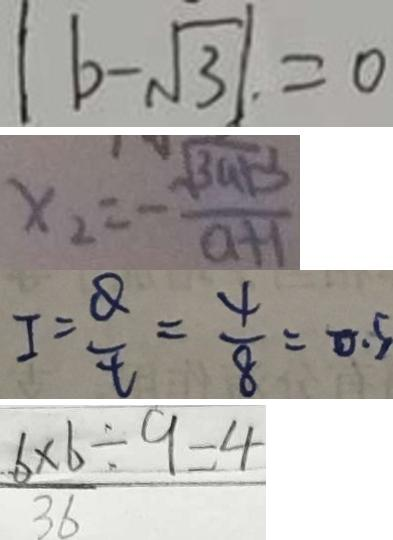Convert formula to latex. <formula><loc_0><loc_0><loc_500><loc_500>\vert b - \sqrt { 3 } \vert . = 0 
 x _ { 2 } = - \frac { \sqrt { 3 a + 3 } } { a + 1 } 
 I = \frac { Q } { t } = \frac { 4 } { 8 } = 0 . 5 
 \frac { 6 \times 6 } { 3 6 } \div 9 = 4</formula> 